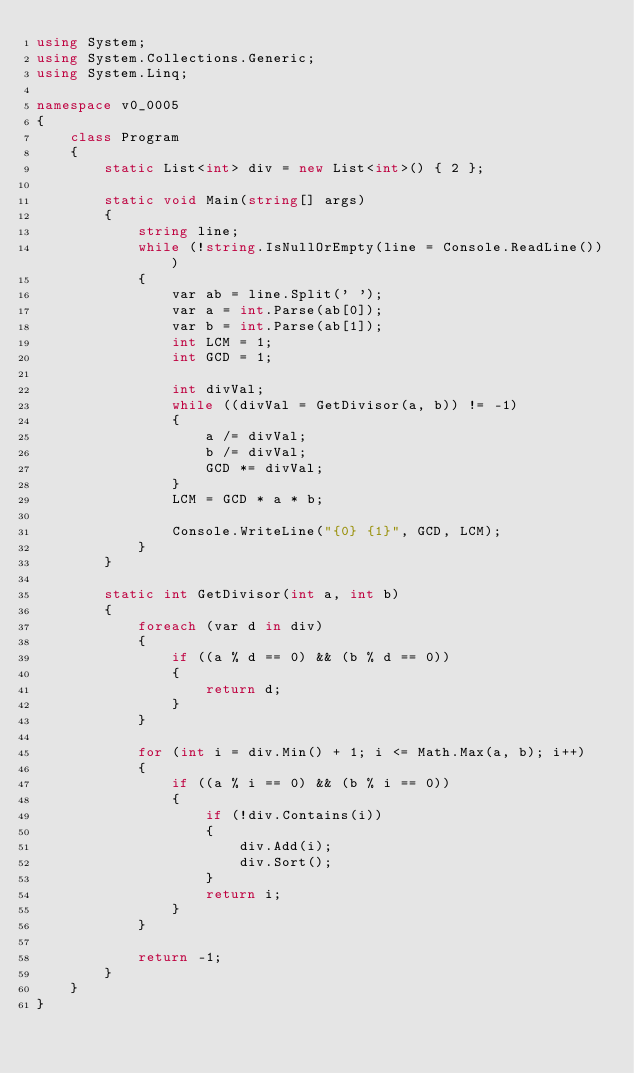<code> <loc_0><loc_0><loc_500><loc_500><_C#_>using System;
using System.Collections.Generic;
using System.Linq;

namespace v0_0005
{
    class Program
    {
        static List<int> div = new List<int>() { 2 };

        static void Main(string[] args)
        {
            string line;
            while (!string.IsNullOrEmpty(line = Console.ReadLine()))
            {
                var ab = line.Split(' ');
                var a = int.Parse(ab[0]);
                var b = int.Parse(ab[1]);
                int LCM = 1;
                int GCD = 1;

                int divVal;
                while ((divVal = GetDivisor(a, b)) != -1)
                {
                    a /= divVal;
                    b /= divVal;
                    GCD *= divVal;
                }
                LCM = GCD * a * b;

                Console.WriteLine("{0} {1}", GCD, LCM);
            }
        }

        static int GetDivisor(int a, int b)
        {
            foreach (var d in div)
            {
                if ((a % d == 0) && (b % d == 0))
                {
                    return d;
                }
            }

            for (int i = div.Min() + 1; i <= Math.Max(a, b); i++)
            {
                if ((a % i == 0) && (b % i == 0))
                {
                    if (!div.Contains(i))
                    {
                        div.Add(i);
                        div.Sort();
                    }
                    return i;
                }
            }

            return -1;
        }
    }
}</code> 